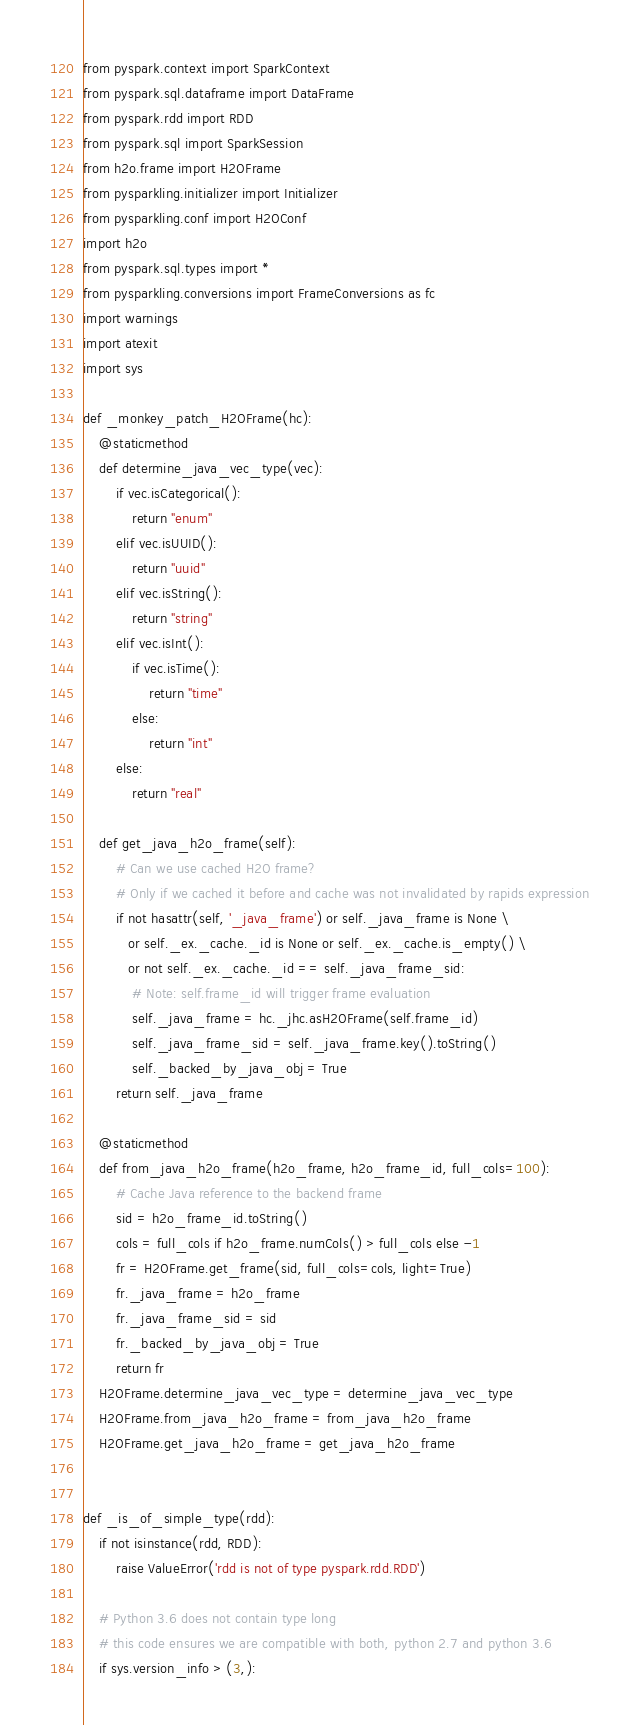<code> <loc_0><loc_0><loc_500><loc_500><_Python_>from pyspark.context import SparkContext
from pyspark.sql.dataframe import DataFrame
from pyspark.rdd import RDD
from pyspark.sql import SparkSession
from h2o.frame import H2OFrame
from pysparkling.initializer import Initializer
from pysparkling.conf import H2OConf
import h2o
from pyspark.sql.types import *
from pysparkling.conversions import FrameConversions as fc
import warnings
import atexit
import sys

def _monkey_patch_H2OFrame(hc):
    @staticmethod
    def determine_java_vec_type(vec):
        if vec.isCategorical():
            return "enum"
        elif vec.isUUID():
            return "uuid"
        elif vec.isString():
            return "string"
        elif vec.isInt():
            if vec.isTime():
                return "time"
            else:
                return "int"
        else:
            return "real"

    def get_java_h2o_frame(self):
        # Can we use cached H2O frame?
        # Only if we cached it before and cache was not invalidated by rapids expression
        if not hasattr(self, '_java_frame') or self._java_frame is None \
           or self._ex._cache._id is None or self._ex._cache.is_empty() \
           or not self._ex._cache._id == self._java_frame_sid:
            # Note: self.frame_id will trigger frame evaluation
            self._java_frame = hc._jhc.asH2OFrame(self.frame_id)
            self._java_frame_sid = self._java_frame.key().toString()
            self._backed_by_java_obj = True
        return self._java_frame

    @staticmethod
    def from_java_h2o_frame(h2o_frame, h2o_frame_id, full_cols=100):
        # Cache Java reference to the backend frame
        sid = h2o_frame_id.toString()
        cols = full_cols if h2o_frame.numCols() > full_cols else -1
        fr = H2OFrame.get_frame(sid, full_cols=cols, light=True)
        fr._java_frame = h2o_frame
        fr._java_frame_sid = sid
        fr._backed_by_java_obj = True
        return fr
    H2OFrame.determine_java_vec_type = determine_java_vec_type
    H2OFrame.from_java_h2o_frame = from_java_h2o_frame
    H2OFrame.get_java_h2o_frame = get_java_h2o_frame


def _is_of_simple_type(rdd):
    if not isinstance(rdd, RDD):
        raise ValueError('rdd is not of type pyspark.rdd.RDD')

    # Python 3.6 does not contain type long
    # this code ensures we are compatible with both, python 2.7 and python 3.6
    if sys.version_info > (3,):</code> 